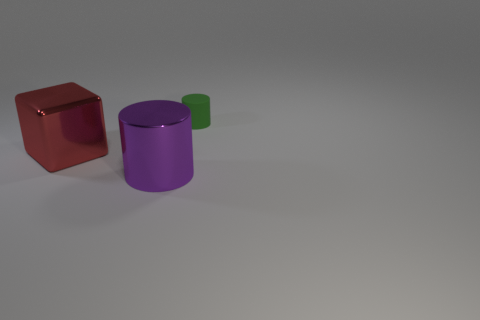Add 3 purple things. How many objects exist? 6 Subtract all cylinders. How many objects are left? 1 Add 1 big red metal things. How many big red metal things are left? 2 Add 1 cyan cylinders. How many cyan cylinders exist? 1 Subtract 0 blue cylinders. How many objects are left? 3 Subtract all gray cubes. Subtract all small objects. How many objects are left? 2 